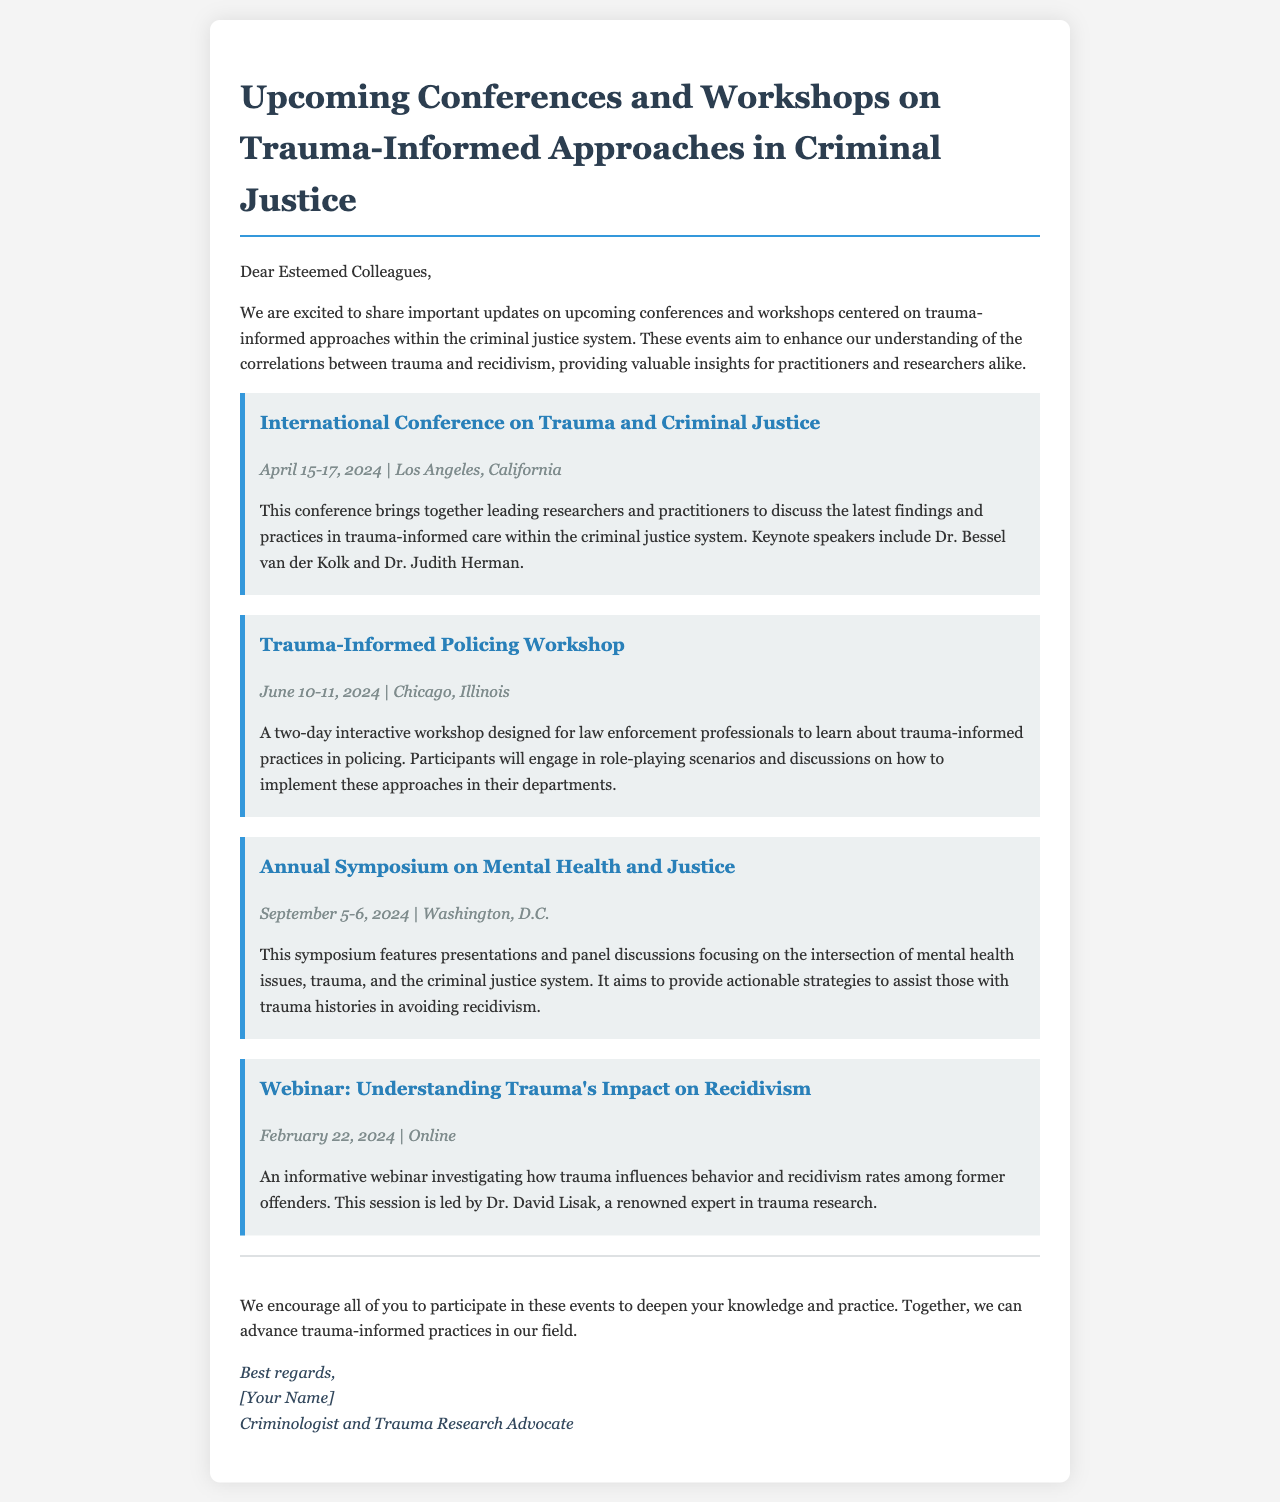What is the title of the newsletter? The title of the newsletter is presented at the top of the document.
Answer: Upcoming Conferences and Workshops on Trauma-Informed Approaches in Criminal Justice Who is one of the keynote speakers at the International Conference on Trauma and Criminal Justice? The document lists keynote speakers for the conference event.
Answer: Dr. Bessel van der Kolk What is the date of the Trauma-Informed Policing Workshop? The date is specified in the event details of the workshop in the document.
Answer: June 10-11, 2024 What city will host the Annual Symposium on Mental Health and Justice? The city for the symposium is mentioned in the event details.
Answer: Washington, D.C Which event is scheduled online? The document outlines the nature and format of the listed events, allowing for specific identification.
Answer: Webinar: Understanding Trauma's Impact on Recidivism What is the main focus of the Annual Symposium on Mental Health and Justice? The focus is described in the summary of the symposium provided in the document.
Answer: Intersection of mental health issues, trauma, and the criminal justice system How many events are listed in the newsletter? The number of events can be counted from the document.
Answer: Four 